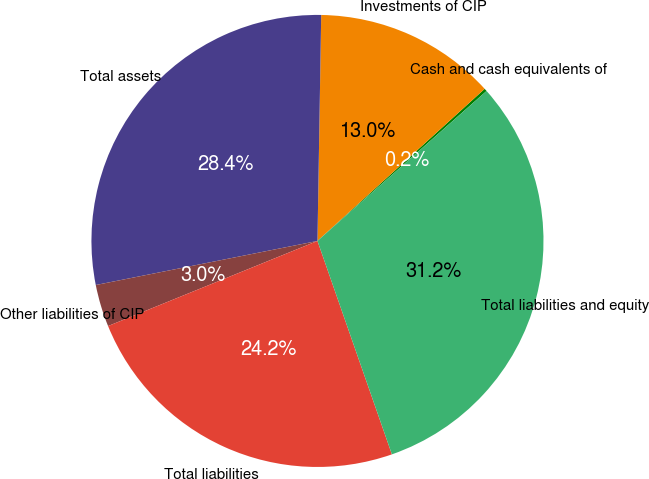<chart> <loc_0><loc_0><loc_500><loc_500><pie_chart><fcel>Cash and cash equivalents of<fcel>Investments of CIP<fcel>Total assets<fcel>Other liabilities of CIP<fcel>Total liabilities<fcel>Total liabilities and equity<nl><fcel>0.2%<fcel>12.99%<fcel>28.39%<fcel>3.02%<fcel>24.2%<fcel>31.21%<nl></chart> 